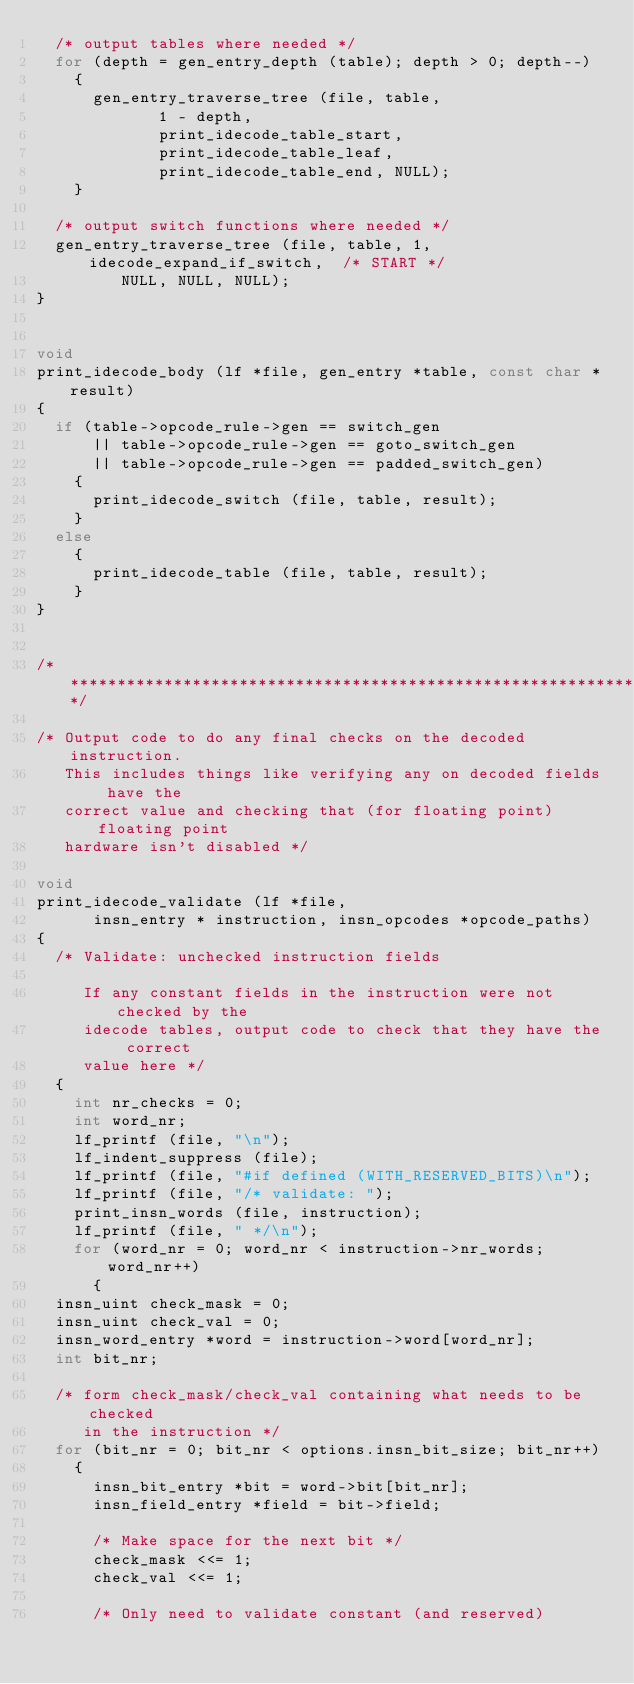<code> <loc_0><loc_0><loc_500><loc_500><_C_>  /* output tables where needed */
  for (depth = gen_entry_depth (table); depth > 0; depth--)
    {
      gen_entry_traverse_tree (file, table,
			       1 - depth,
			       print_idecode_table_start,
			       print_idecode_table_leaf,
			       print_idecode_table_end, NULL);
    }

  /* output switch functions where needed */
  gen_entry_traverse_tree (file, table, 1, idecode_expand_if_switch,	/* START */
			   NULL, NULL, NULL);
}


void
print_idecode_body (lf *file, gen_entry *table, const char *result)
{
  if (table->opcode_rule->gen == switch_gen
      || table->opcode_rule->gen == goto_switch_gen
      || table->opcode_rule->gen == padded_switch_gen)
    {
      print_idecode_switch (file, table, result);
    }
  else
    {
      print_idecode_table (file, table, result);
    }
}


/****************************************************************/

/* Output code to do any final checks on the decoded instruction.
   This includes things like verifying any on decoded fields have the
   correct value and checking that (for floating point) floating point
   hardware isn't disabled */

void
print_idecode_validate (lf *file,
			insn_entry * instruction, insn_opcodes *opcode_paths)
{
  /* Validate: unchecked instruction fields

     If any constant fields in the instruction were not checked by the
     idecode tables, output code to check that they have the correct
     value here */
  {
    int nr_checks = 0;
    int word_nr;
    lf_printf (file, "\n");
    lf_indent_suppress (file);
    lf_printf (file, "#if defined (WITH_RESERVED_BITS)\n");
    lf_printf (file, "/* validate: ");
    print_insn_words (file, instruction);
    lf_printf (file, " */\n");
    for (word_nr = 0; word_nr < instruction->nr_words; word_nr++)
      {
	insn_uint check_mask = 0;
	insn_uint check_val = 0;
	insn_word_entry *word = instruction->word[word_nr];
	int bit_nr;

	/* form check_mask/check_val containing what needs to be checked
	   in the instruction */
	for (bit_nr = 0; bit_nr < options.insn_bit_size; bit_nr++)
	  {
	    insn_bit_entry *bit = word->bit[bit_nr];
	    insn_field_entry *field = bit->field;

	    /* Make space for the next bit */
	    check_mask <<= 1;
	    check_val <<= 1;

	    /* Only need to validate constant (and reserved)</code> 